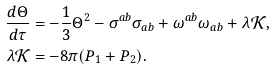Convert formula to latex. <formula><loc_0><loc_0><loc_500><loc_500>\frac { d \Theta } { d \tau } & = - \frac { 1 } { 3 } \Theta ^ { 2 } - \sigma ^ { a b } \sigma _ { a b } + \omega ^ { a b } \omega _ { a b } + \lambda \mathcal { K } , \\ \lambda \mathcal { K } & = - 8 \pi ( P _ { 1 } + P _ { 2 } ) .</formula> 